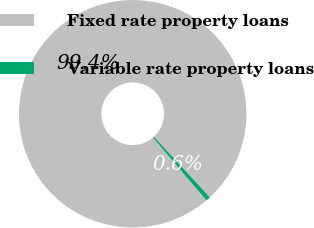<chart> <loc_0><loc_0><loc_500><loc_500><pie_chart><fcel>Fixed rate property loans<fcel>Variable rate property loans<nl><fcel>99.36%<fcel>0.64%<nl></chart> 